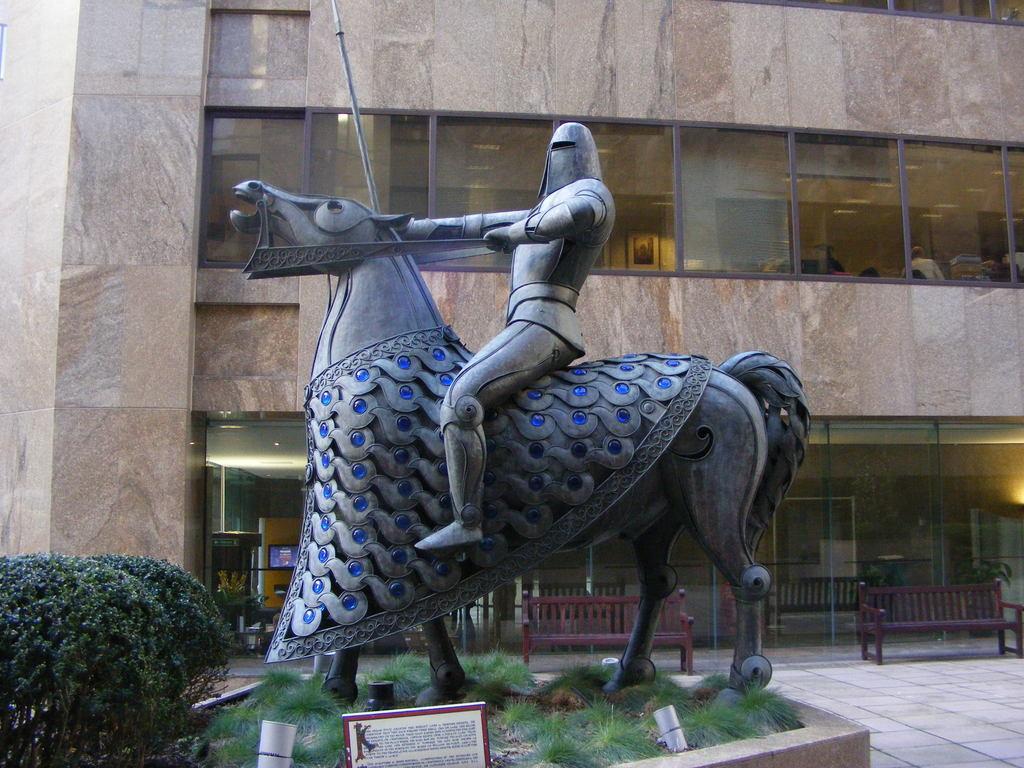Could you give a brief overview of what you see in this image? In this picture, we see the statue of the man riding the horse. At the bottom, we see the grass, lights and a board in white color with some text written on it. On the left side, we see the shrubs or trees. Behind the statue, we see the benches and the railing. In the background, we see a building in brown color. This building has the glass windows. 